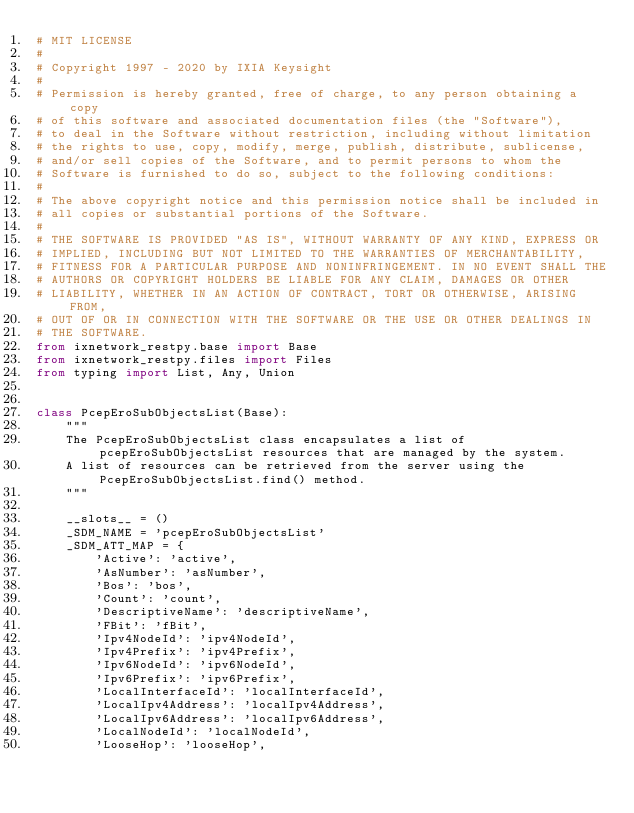Convert code to text. <code><loc_0><loc_0><loc_500><loc_500><_Python_># MIT LICENSE
#
# Copyright 1997 - 2020 by IXIA Keysight
#
# Permission is hereby granted, free of charge, to any person obtaining a copy
# of this software and associated documentation files (the "Software"),
# to deal in the Software without restriction, including without limitation
# the rights to use, copy, modify, merge, publish, distribute, sublicense,
# and/or sell copies of the Software, and to permit persons to whom the
# Software is furnished to do so, subject to the following conditions:
#
# The above copyright notice and this permission notice shall be included in
# all copies or substantial portions of the Software.
#
# THE SOFTWARE IS PROVIDED "AS IS", WITHOUT WARRANTY OF ANY KIND, EXPRESS OR
# IMPLIED, INCLUDING BUT NOT LIMITED TO THE WARRANTIES OF MERCHANTABILITY,
# FITNESS FOR A PARTICULAR PURPOSE AND NONINFRINGEMENT. IN NO EVENT SHALL THE
# AUTHORS OR COPYRIGHT HOLDERS BE LIABLE FOR ANY CLAIM, DAMAGES OR OTHER
# LIABILITY, WHETHER IN AN ACTION OF CONTRACT, TORT OR OTHERWISE, ARISING FROM,
# OUT OF OR IN CONNECTION WITH THE SOFTWARE OR THE USE OR OTHER DEALINGS IN
# THE SOFTWARE. 
from ixnetwork_restpy.base import Base
from ixnetwork_restpy.files import Files
from typing import List, Any, Union


class PcepEroSubObjectsList(Base):
    """
    The PcepEroSubObjectsList class encapsulates a list of pcepEroSubObjectsList resources that are managed by the system.
    A list of resources can be retrieved from the server using the PcepEroSubObjectsList.find() method.
    """

    __slots__ = ()
    _SDM_NAME = 'pcepEroSubObjectsList'
    _SDM_ATT_MAP = {
        'Active': 'active',
        'AsNumber': 'asNumber',
        'Bos': 'bos',
        'Count': 'count',
        'DescriptiveName': 'descriptiveName',
        'FBit': 'fBit',
        'Ipv4NodeId': 'ipv4NodeId',
        'Ipv4Prefix': 'ipv4Prefix',
        'Ipv6NodeId': 'ipv6NodeId',
        'Ipv6Prefix': 'ipv6Prefix',
        'LocalInterfaceId': 'localInterfaceId',
        'LocalIpv4Address': 'localIpv4Address',
        'LocalIpv6Address': 'localIpv6Address',
        'LocalNodeId': 'localNodeId',
        'LooseHop': 'looseHop',</code> 